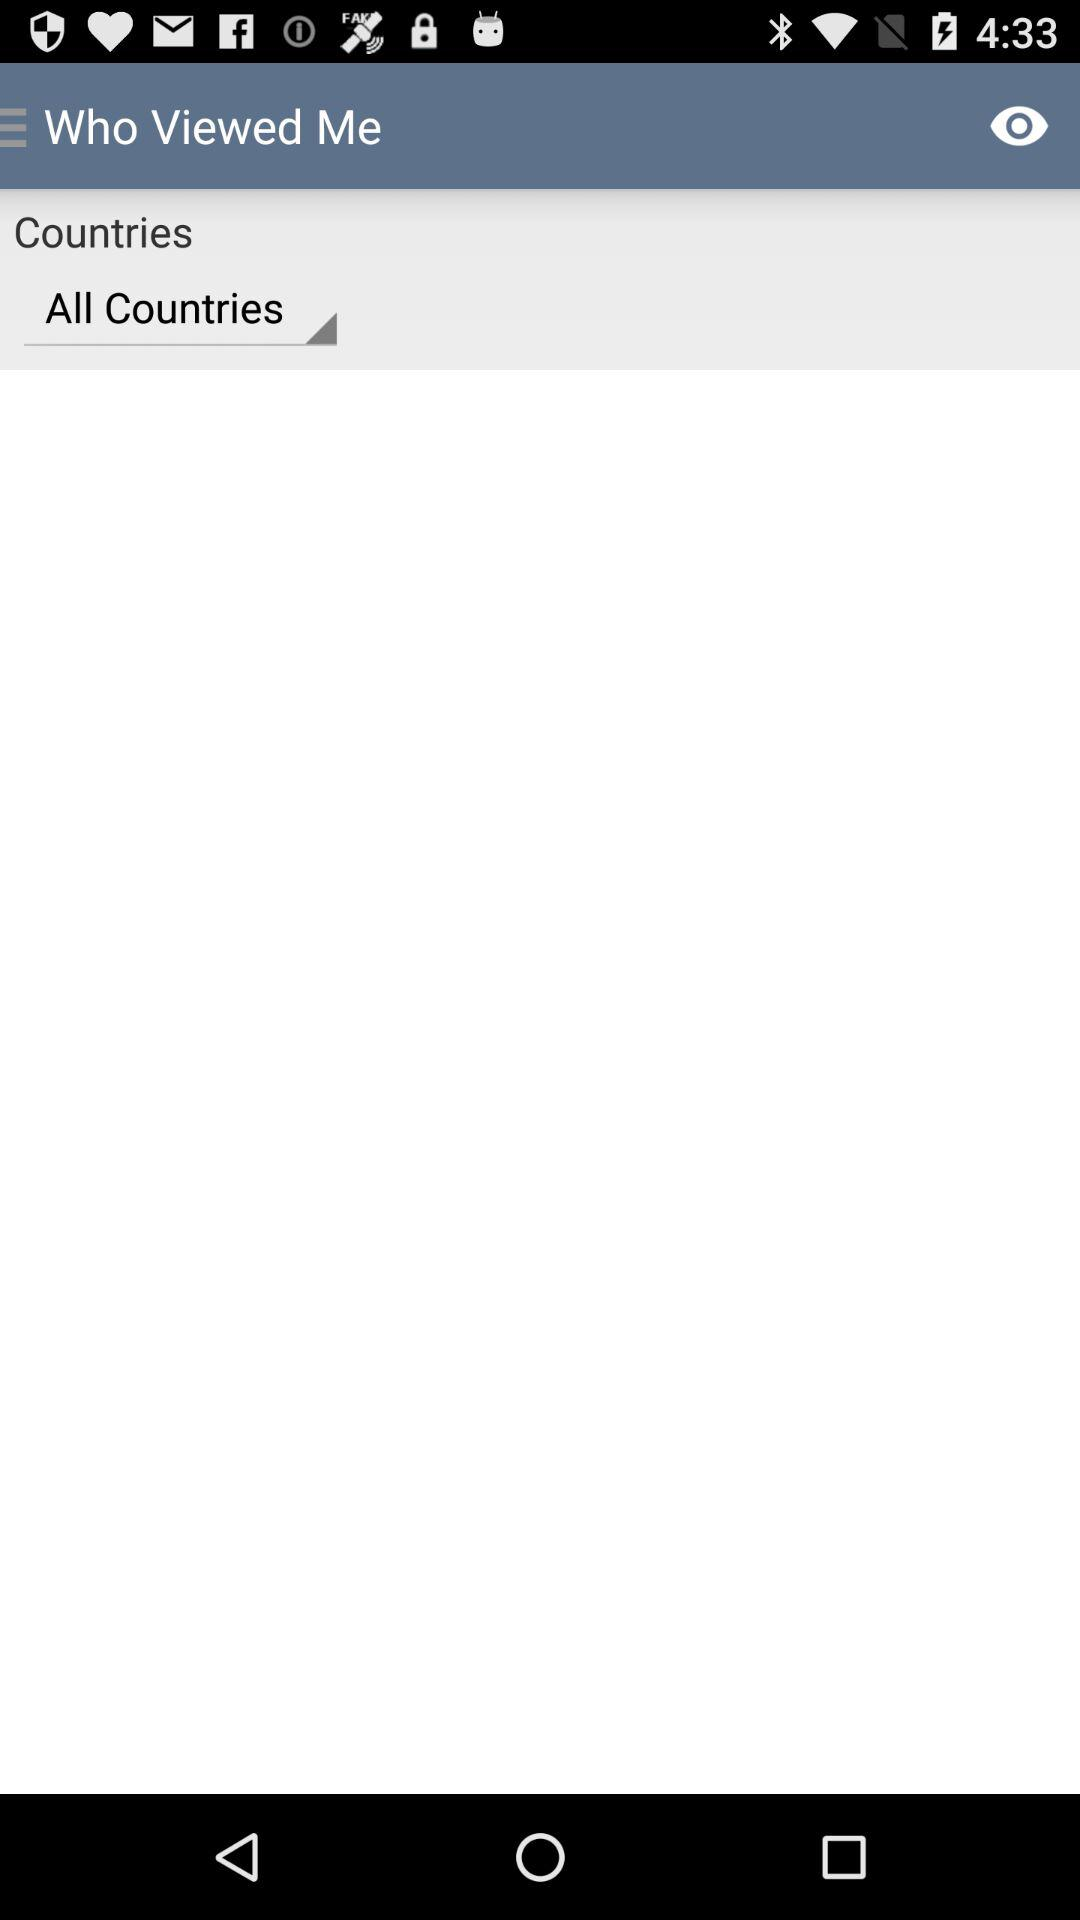Which option is selected in "Countries"? The selected option in "Countries" is "All Countries". 